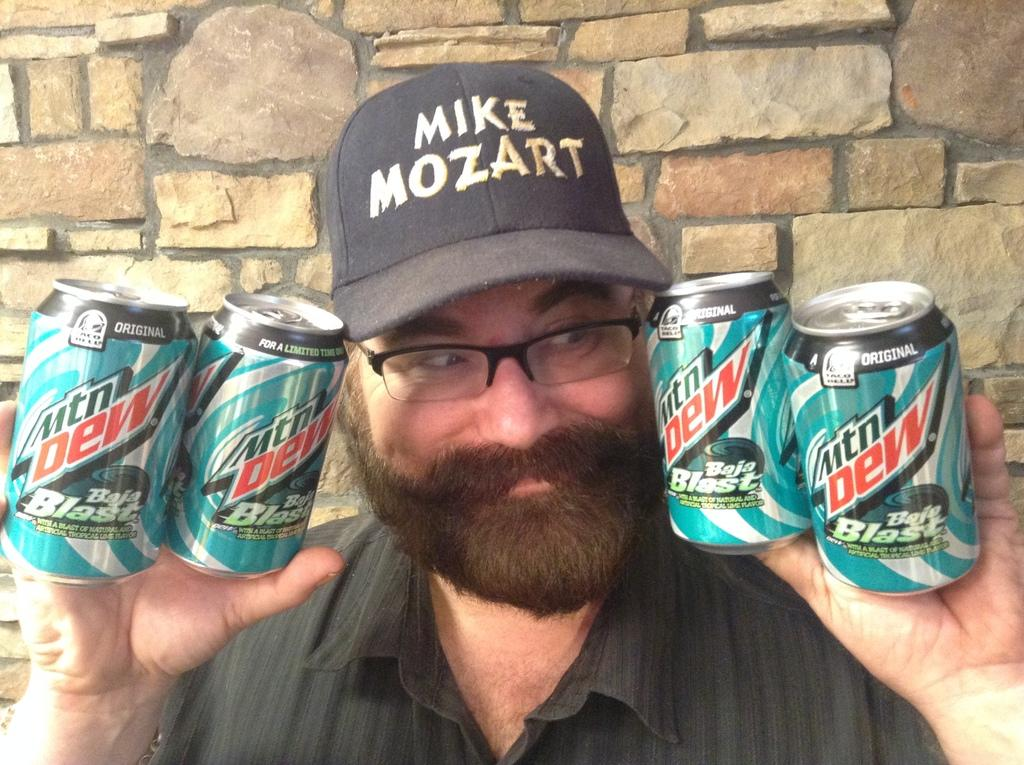<image>
Offer a succinct explanation of the picture presented. a hat with mike mozart written on it and several mountain dew cans 